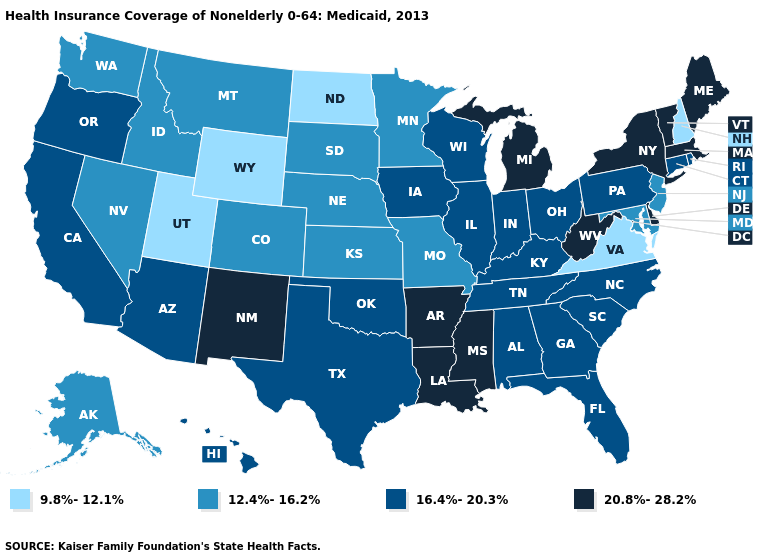Does the map have missing data?
Give a very brief answer. No. Does New Hampshire have the highest value in the Northeast?
Answer briefly. No. Does Michigan have the lowest value in the MidWest?
Concise answer only. No. What is the value of Nebraska?
Short answer required. 12.4%-16.2%. How many symbols are there in the legend?
Concise answer only. 4. What is the value of Virginia?
Short answer required. 9.8%-12.1%. Name the states that have a value in the range 12.4%-16.2%?
Answer briefly. Alaska, Colorado, Idaho, Kansas, Maryland, Minnesota, Missouri, Montana, Nebraska, Nevada, New Jersey, South Dakota, Washington. Name the states that have a value in the range 20.8%-28.2%?
Answer briefly. Arkansas, Delaware, Louisiana, Maine, Massachusetts, Michigan, Mississippi, New Mexico, New York, Vermont, West Virginia. How many symbols are there in the legend?
Concise answer only. 4. Among the states that border Utah , does New Mexico have the highest value?
Quick response, please. Yes. Name the states that have a value in the range 9.8%-12.1%?
Concise answer only. New Hampshire, North Dakota, Utah, Virginia, Wyoming. Does New Mexico have the lowest value in the USA?
Write a very short answer. No. What is the value of Pennsylvania?
Short answer required. 16.4%-20.3%. Among the states that border New Mexico , does Colorado have the highest value?
Answer briefly. No. Among the states that border North Carolina , which have the highest value?
Short answer required. Georgia, South Carolina, Tennessee. 